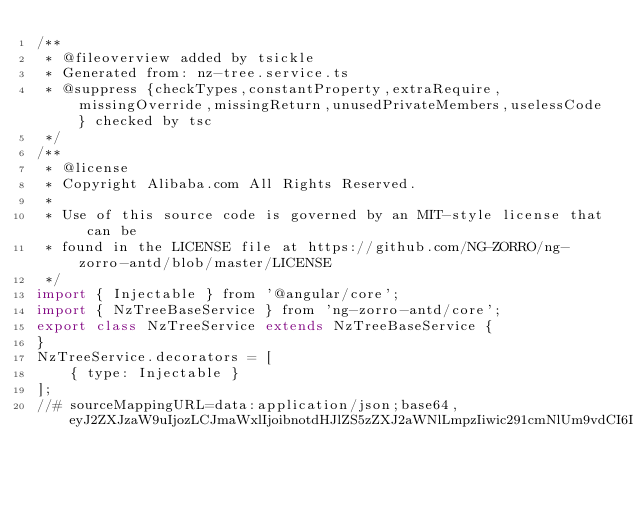Convert code to text. <code><loc_0><loc_0><loc_500><loc_500><_JavaScript_>/**
 * @fileoverview added by tsickle
 * Generated from: nz-tree.service.ts
 * @suppress {checkTypes,constantProperty,extraRequire,missingOverride,missingReturn,unusedPrivateMembers,uselessCode} checked by tsc
 */
/**
 * @license
 * Copyright Alibaba.com All Rights Reserved.
 *
 * Use of this source code is governed by an MIT-style license that can be
 * found in the LICENSE file at https://github.com/NG-ZORRO/ng-zorro-antd/blob/master/LICENSE
 */
import { Injectable } from '@angular/core';
import { NzTreeBaseService } from 'ng-zorro-antd/core';
export class NzTreeService extends NzTreeBaseService {
}
NzTreeService.decorators = [
    { type: Injectable }
];
//# sourceMappingURL=data:application/json;base64,eyJ2ZXJzaW9uIjozLCJmaWxlIjoibnotdHJlZS5zZXJ2aWNlLmpzIiwic291cmNlUm9vdCI6Im5nOi8vbmctem9ycm8tYW50ZC90cmVlLyIsInNvdXJjZXMiOlsibnotdHJlZS5zZXJ2aWNlLnRzIl0sIm5hbWVzIjpbXSwibWFwcGluZ3MiOiI7Ozs7Ozs7Ozs7OztBQVFBLE9BQU8sRUFBRSxVQUFVLEVBQUUsTUFBTSxlQUFlLENBQUM7QUFDM0MsT0FBTyxFQUFFLGlCQUFpQixFQUFFLE1BQU0sb0JBQW9CLENBQUM7QUFHdkQsTUFBTSxPQUFPLGFBQWMsU0FBUSxpQkFBaUI7OztZQURuRCxVQUFVIiwic291cmNlc0NvbnRlbnQiOlsiLyoqXG4gKiBAbGljZW5zZVxuICogQ29weXJpZ2h0IEFsaWJhYmEuY29tIEFsbCBSaWdodHMgUmVzZXJ2ZWQuXG4gKlxuICogVXNlIG9mIHRoaXMgc291cmNlIGNvZGUgaXMgZ292ZXJuZWQgYnkgYW4gTUlULXN0eWxlIGxpY2Vuc2UgdGhhdCBjYW4gYmVcbiAqIGZvdW5kIGluIHRoZSBMSUNFTlNFIGZpbGUgYXQgaHR0cHM6Ly9naXRodWIuY29tL05HLVpPUlJPL25nLXpvcnJvLWFudGQvYmxvYi9tYXN0ZXIvTElDRU5TRVxuICovXG5cbmltcG9ydCB7IEluamVjdGFibGUgfSBmcm9tICdAYW5ndWxhci9jb3JlJztcbmltcG9ydCB7IE56VHJlZUJhc2VTZXJ2aWNlIH0gZnJvbSAnbmctem9ycm8tYW50ZC9jb3JlJztcblxuQEluamVjdGFibGUoKVxuZXhwb3J0IGNsYXNzIE56VHJlZVNlcnZpY2UgZXh0ZW5kcyBOelRyZWVCYXNlU2VydmljZSB7fVxuIl19</code> 